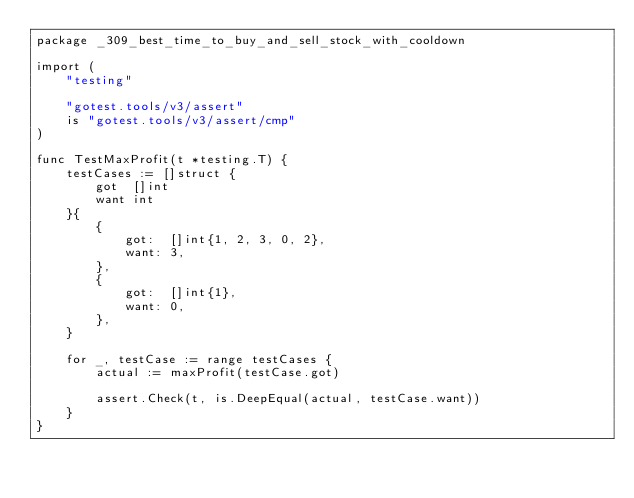Convert code to text. <code><loc_0><loc_0><loc_500><loc_500><_Go_>package _309_best_time_to_buy_and_sell_stock_with_cooldown

import (
	"testing"

	"gotest.tools/v3/assert"
	is "gotest.tools/v3/assert/cmp"
)

func TestMaxProfit(t *testing.T) {
	testCases := []struct {
		got  []int
		want int
	}{
		{
			got:  []int{1, 2, 3, 0, 2},
			want: 3,
		},
		{
			got:  []int{1},
			want: 0,
		},
	}

	for _, testCase := range testCases {
		actual := maxProfit(testCase.got)

		assert.Check(t, is.DeepEqual(actual, testCase.want))
	}
}
</code> 